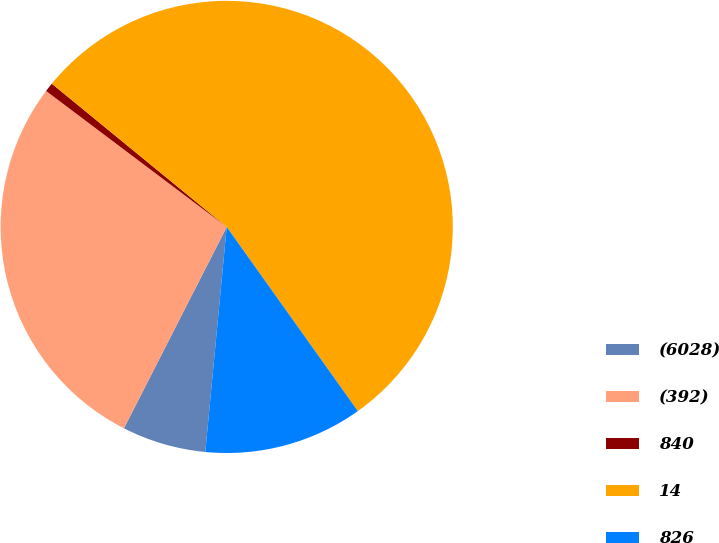Convert chart. <chart><loc_0><loc_0><loc_500><loc_500><pie_chart><fcel>(6028)<fcel>(392)<fcel>840<fcel>14<fcel>826<nl><fcel>6.0%<fcel>27.76%<fcel>0.65%<fcel>54.23%<fcel>11.36%<nl></chart> 